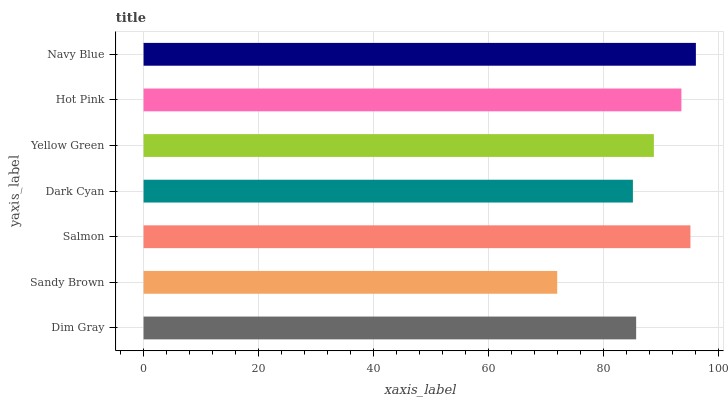Is Sandy Brown the minimum?
Answer yes or no. Yes. Is Navy Blue the maximum?
Answer yes or no. Yes. Is Salmon the minimum?
Answer yes or no. No. Is Salmon the maximum?
Answer yes or no. No. Is Salmon greater than Sandy Brown?
Answer yes or no. Yes. Is Sandy Brown less than Salmon?
Answer yes or no. Yes. Is Sandy Brown greater than Salmon?
Answer yes or no. No. Is Salmon less than Sandy Brown?
Answer yes or no. No. Is Yellow Green the high median?
Answer yes or no. Yes. Is Yellow Green the low median?
Answer yes or no. Yes. Is Navy Blue the high median?
Answer yes or no. No. Is Sandy Brown the low median?
Answer yes or no. No. 